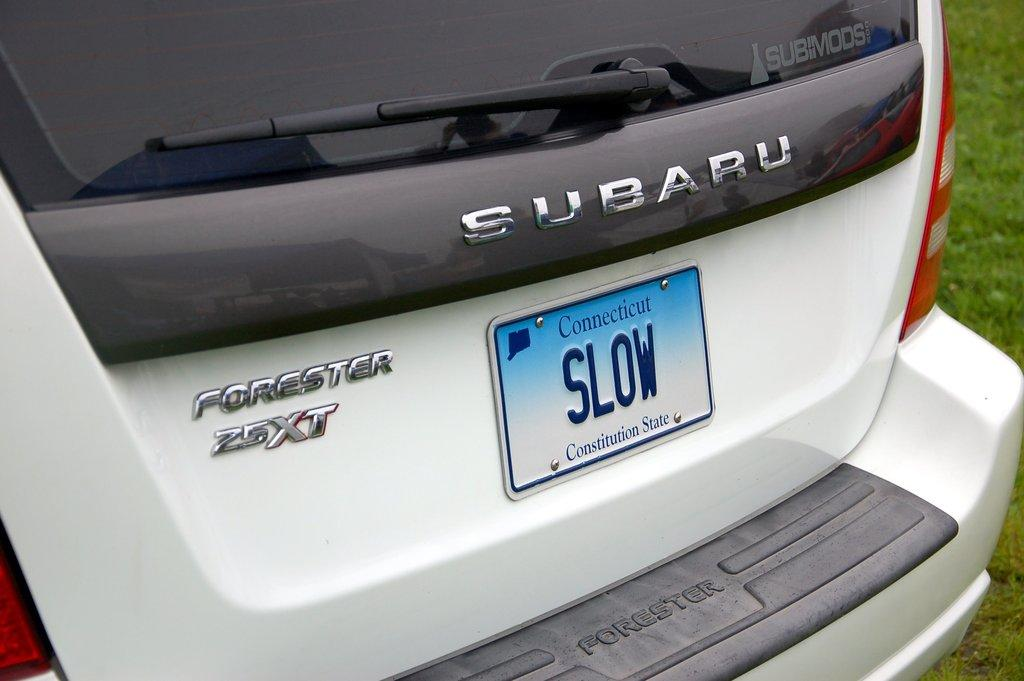<image>
Create a compact narrative representing the image presented. A Connecticut license plate on a Subaru says "Slow." 